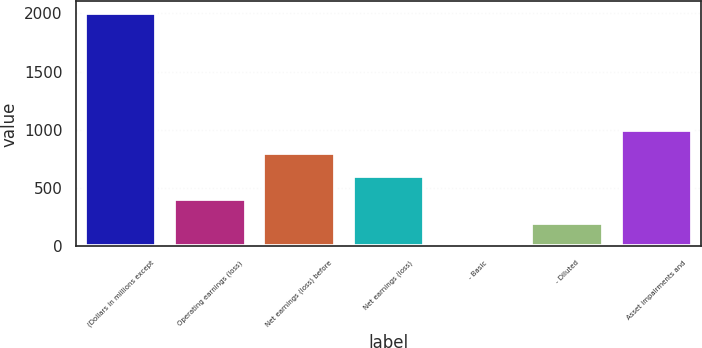Convert chart. <chart><loc_0><loc_0><loc_500><loc_500><bar_chart><fcel>(Dollars in millions except<fcel>Operating earnings (loss)<fcel>Net earnings (loss) before<fcel>Net earnings (loss)<fcel>- Basic<fcel>- Diluted<fcel>Asset impairments and<nl><fcel>2003<fcel>403.4<fcel>803.3<fcel>603.35<fcel>3.5<fcel>203.45<fcel>1003.25<nl></chart> 